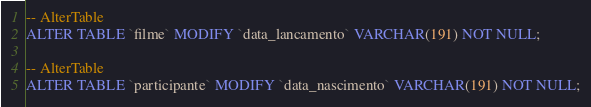<code> <loc_0><loc_0><loc_500><loc_500><_SQL_>-- AlterTable
ALTER TABLE `filme` MODIFY `data_lancamento` VARCHAR(191) NOT NULL;

-- AlterTable
ALTER TABLE `participante` MODIFY `data_nascimento` VARCHAR(191) NOT NULL;
</code> 